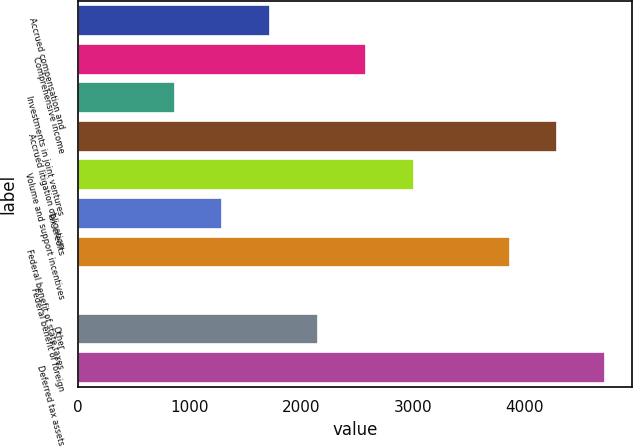<chart> <loc_0><loc_0><loc_500><loc_500><bar_chart><fcel>Accrued compensation and<fcel>Comprehensive income<fcel>Investments in joint ventures<fcel>Accrued litigation obligation<fcel>Volume and support incentives<fcel>Tax credits<fcel>Federal benefit of state taxes<fcel>Federal benefit of foreign<fcel>Other<fcel>Deferred tax assets<nl><fcel>1720.6<fcel>2578.4<fcel>862.8<fcel>4294<fcel>3007.3<fcel>1291.7<fcel>3865.1<fcel>5<fcel>2149.5<fcel>4722.9<nl></chart> 